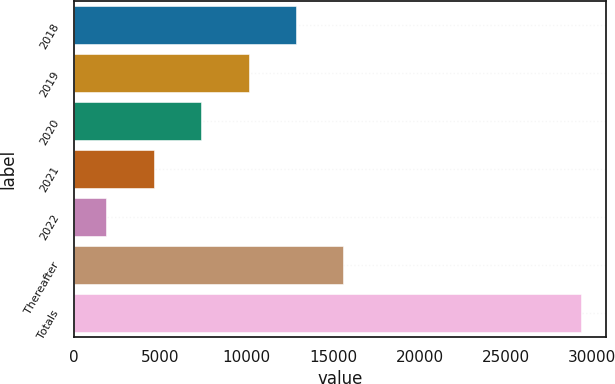Convert chart. <chart><loc_0><loc_0><loc_500><loc_500><bar_chart><fcel>2018<fcel>2019<fcel>2020<fcel>2021<fcel>2022<fcel>Thereafter<fcel>Totals<nl><fcel>12850<fcel>10101.5<fcel>7353<fcel>4604.5<fcel>1856<fcel>15598.5<fcel>29341<nl></chart> 